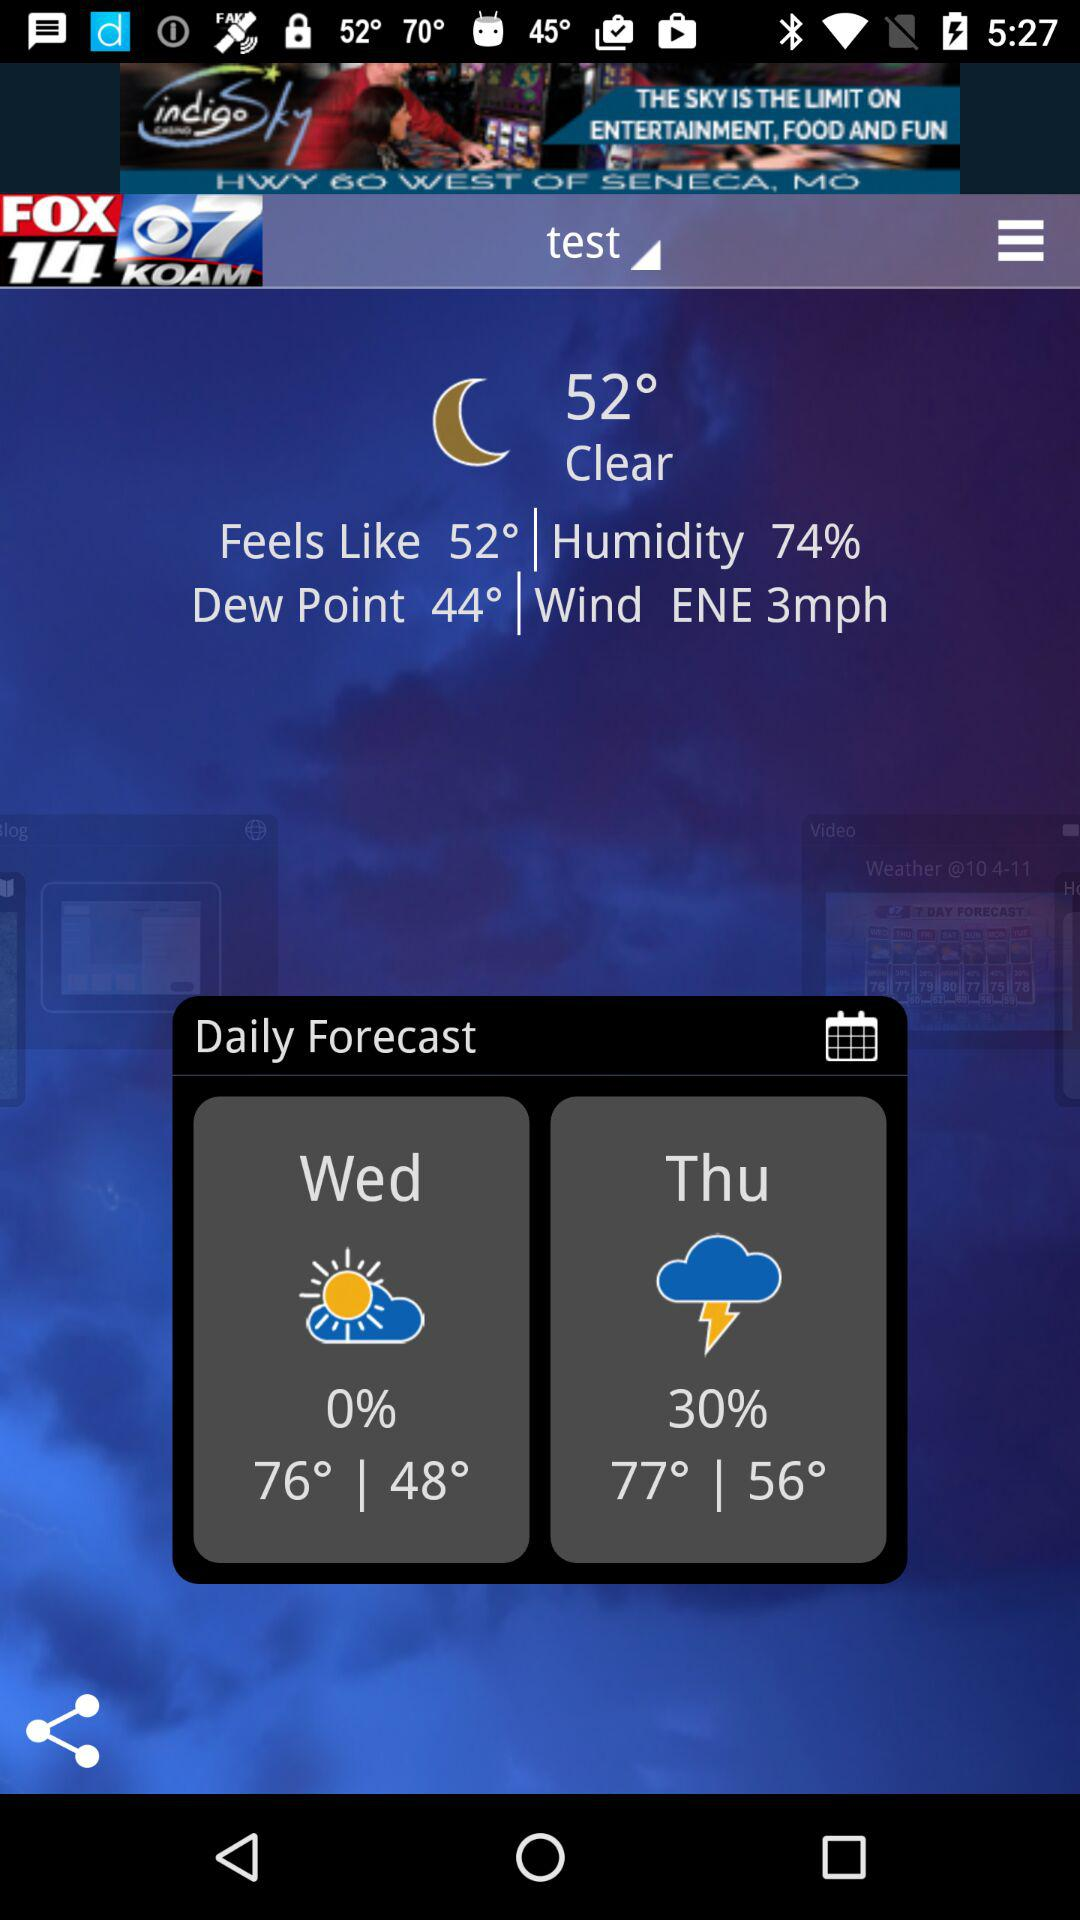How much higher is the temperature on Thursday than Wednesday?
Answer the question using a single word or phrase. 1° 